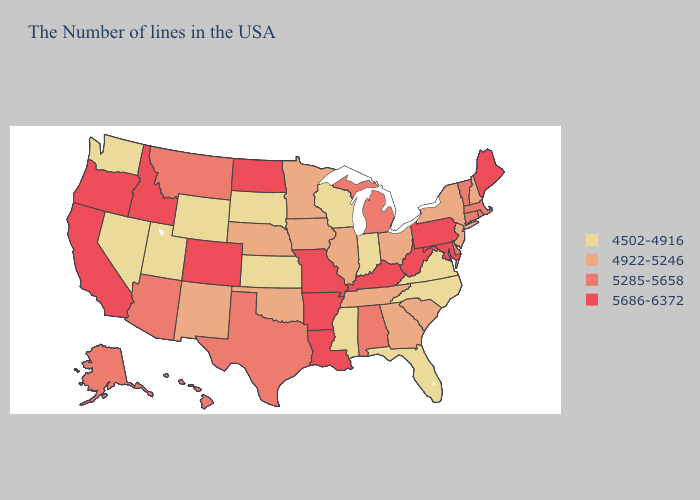Name the states that have a value in the range 4922-5246?
Be succinct. New Hampshire, New York, New Jersey, South Carolina, Ohio, Georgia, Tennessee, Illinois, Minnesota, Iowa, Nebraska, Oklahoma, New Mexico. Does Kansas have the lowest value in the USA?
Quick response, please. Yes. Name the states that have a value in the range 5285-5658?
Short answer required. Massachusetts, Rhode Island, Vermont, Connecticut, Delaware, Michigan, Alabama, Texas, Montana, Arizona, Alaska, Hawaii. Does Wyoming have the lowest value in the West?
Write a very short answer. Yes. Among the states that border New Mexico , does Texas have the highest value?
Concise answer only. No. What is the value of Alabama?
Keep it brief. 5285-5658. Name the states that have a value in the range 5686-6372?
Give a very brief answer. Maine, Maryland, Pennsylvania, West Virginia, Kentucky, Louisiana, Missouri, Arkansas, North Dakota, Colorado, Idaho, California, Oregon. Name the states that have a value in the range 5686-6372?
Be succinct. Maine, Maryland, Pennsylvania, West Virginia, Kentucky, Louisiana, Missouri, Arkansas, North Dakota, Colorado, Idaho, California, Oregon. Name the states that have a value in the range 4922-5246?
Concise answer only. New Hampshire, New York, New Jersey, South Carolina, Ohio, Georgia, Tennessee, Illinois, Minnesota, Iowa, Nebraska, Oklahoma, New Mexico. Does West Virginia have the highest value in the USA?
Short answer required. Yes. Does New Jersey have the same value as Utah?
Be succinct. No. Is the legend a continuous bar?
Be succinct. No. What is the lowest value in states that border Maryland?
Quick response, please. 4502-4916. Does Missouri have the same value as Kentucky?
Be succinct. Yes. Does Florida have the highest value in the USA?
Concise answer only. No. 